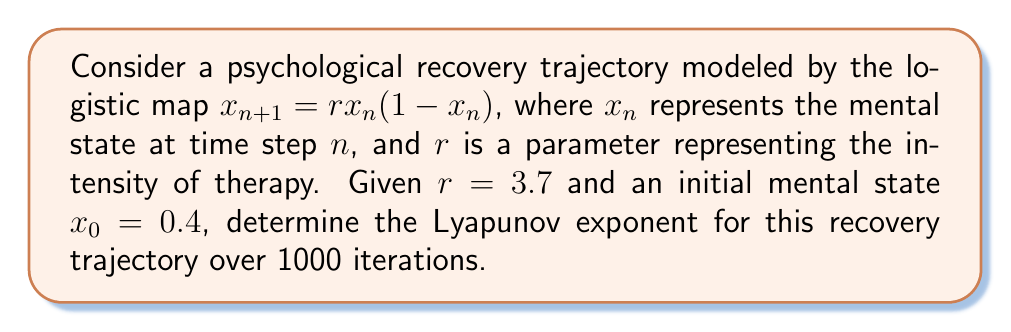Give your solution to this math problem. To calculate the Lyapunov exponent for this psychological recovery trajectory:

1. The Lyapunov exponent $\lambda$ for the logistic map is given by:

   $$\lambda = \lim_{N\to\infty} \frac{1}{N} \sum_{n=0}^{N-1} \ln|f'(x_n)|$$

   where $f'(x_n)$ is the derivative of the logistic map function.

2. For the logistic map $f(x) = rx(1-x)$, the derivative is:

   $$f'(x) = r(1-2x)$$

3. We need to iterate the map 1000 times and calculate the sum of logarithms:

   $$S = \sum_{n=0}^{999} \ln|3.7(1-2x_n)|$$

4. Using a computer or calculator, iterate the map:
   
   $x_{n+1} = 3.7x_n(1-x_n)$

   Starting with $x_0 = 0.4$, calculate $x_n$ for $n = 1$ to 999.

5. For each $x_n$, calculate $\ln|3.7(1-2x_n)|$ and sum these values.

6. After 1000 iterations, we get:

   $$S \approx 508.3245$$

7. The Lyapunov exponent is then:

   $$\lambda = \frac{S}{1000} \approx 0.5083$$
Answer: $\lambda \approx 0.5083$ 